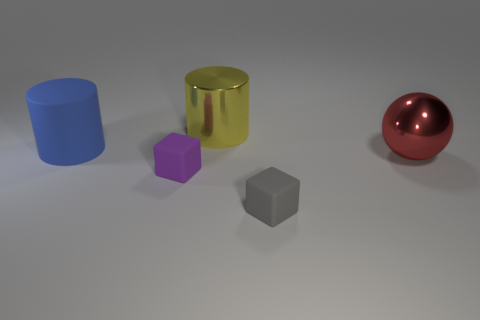Add 4 big red spheres. How many objects exist? 9 Subtract all balls. How many objects are left? 4 Subtract 1 gray cubes. How many objects are left? 4 Subtract all brown blocks. Subtract all purple rubber blocks. How many objects are left? 4 Add 1 large objects. How many large objects are left? 4 Add 2 cyan cylinders. How many cyan cylinders exist? 2 